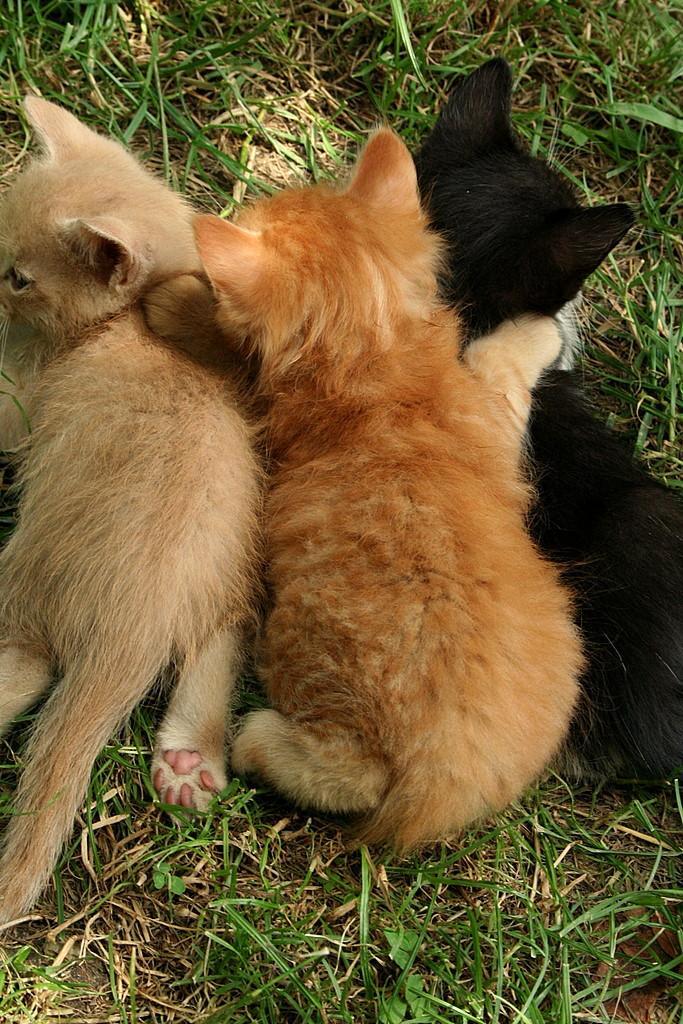How would you summarize this image in a sentence or two? In this picture I can see cats lying on the ground. The cat on the right side is black in color. I can also see the grass. 